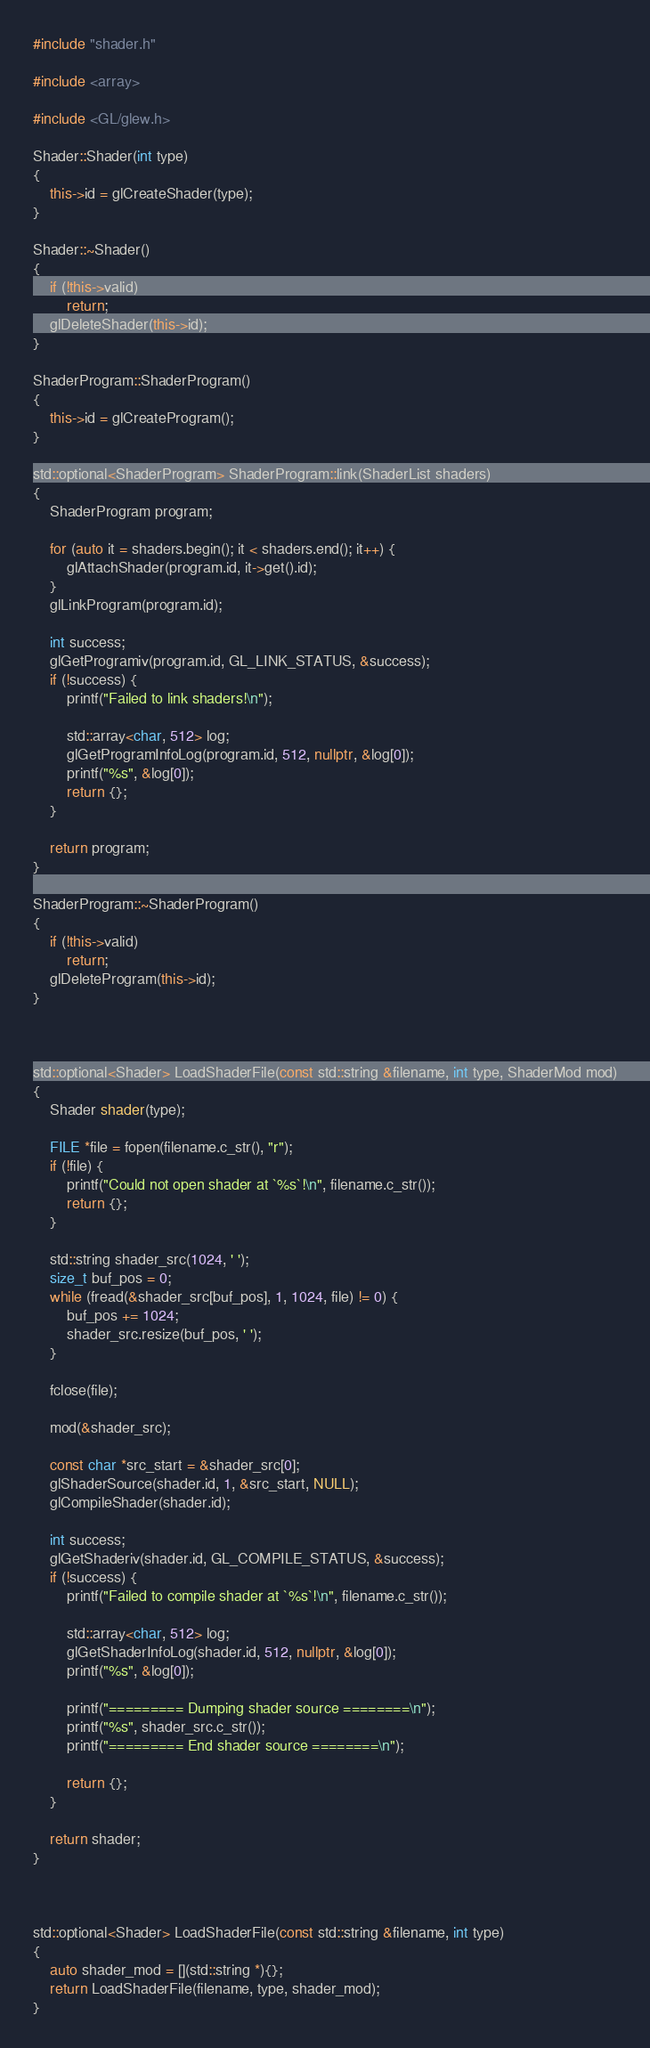Convert code to text. <code><loc_0><loc_0><loc_500><loc_500><_C++_>#include "shader.h"

#include <array>

#include <GL/glew.h>

Shader::Shader(int type)
{
    this->id = glCreateShader(type);
}

Shader::~Shader()
{
    if (!this->valid)
        return;
    glDeleteShader(this->id);
}

ShaderProgram::ShaderProgram()
{
    this->id = glCreateProgram();
}

std::optional<ShaderProgram> ShaderProgram::link(ShaderList shaders)
{
    ShaderProgram program;

    for (auto it = shaders.begin(); it < shaders.end(); it++) {
        glAttachShader(program.id, it->get().id);
    }
    glLinkProgram(program.id);

    int success;
    glGetProgramiv(program.id, GL_LINK_STATUS, &success);
    if (!success) {
        printf("Failed to link shaders!\n");

        std::array<char, 512> log;
        glGetProgramInfoLog(program.id, 512, nullptr, &log[0]);
        printf("%s", &log[0]);
        return {};
    }

    return program;
}

ShaderProgram::~ShaderProgram()
{
    if (!this->valid)
        return;
    glDeleteProgram(this->id);
}



std::optional<Shader> LoadShaderFile(const std::string &filename, int type, ShaderMod mod)
{
    Shader shader(type);
    
    FILE *file = fopen(filename.c_str(), "r");
    if (!file) {
        printf("Could not open shader at `%s`!\n", filename.c_str());
        return {};
    }

    std::string shader_src(1024, ' ');
    size_t buf_pos = 0;
    while (fread(&shader_src[buf_pos], 1, 1024, file) != 0) {
        buf_pos += 1024;
        shader_src.resize(buf_pos, ' ');
    }

    fclose(file);

    mod(&shader_src);

    const char *src_start = &shader_src[0];
    glShaderSource(shader.id, 1, &src_start, NULL);
    glCompileShader(shader.id);

    int success;
    glGetShaderiv(shader.id, GL_COMPILE_STATUS, &success);
    if (!success) {
        printf("Failed to compile shader at `%s`!\n", filename.c_str());

        std::array<char, 512> log;
        glGetShaderInfoLog(shader.id, 512, nullptr, &log[0]);
        printf("%s", &log[0]);

        printf("========= Dumping shader source ========\n");
        printf("%s", shader_src.c_str());
        printf("========= End shader source ========\n");

        return {};
    }

    return shader;
}



std::optional<Shader> LoadShaderFile(const std::string &filename, int type)
{
    auto shader_mod = [](std::string *){};
    return LoadShaderFile(filename, type, shader_mod);
}</code> 